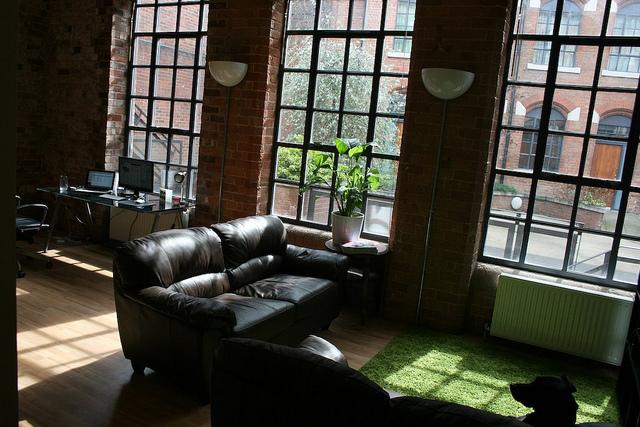Does this look like a comfortable couch?
Short answer required. Yes. What kind of heater is this room using?
Answer briefly. Radiator. Where is the dog in this picture?
Be succinct. Couch. 